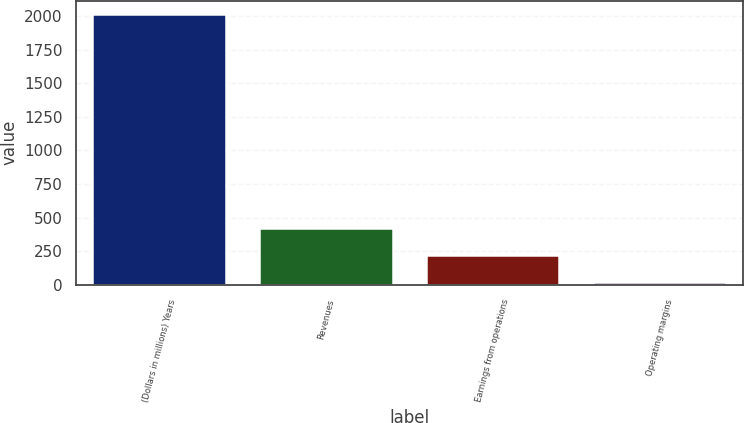Convert chart. <chart><loc_0><loc_0><loc_500><loc_500><bar_chart><fcel>(Dollars in millions) Years<fcel>Revenues<fcel>Earnings from operations<fcel>Operating margins<nl><fcel>2014<fcel>420.4<fcel>221.2<fcel>22<nl></chart> 